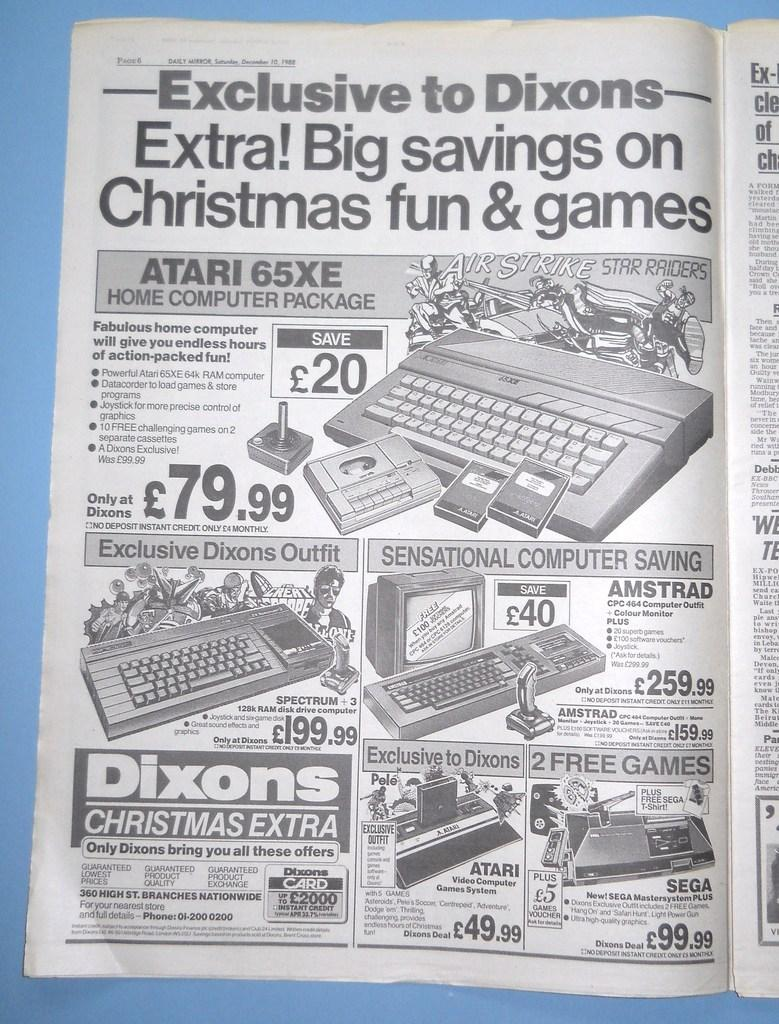<image>
Give a short and clear explanation of the subsequent image. White and black ad for Dixons selling the Atari 65XE. 